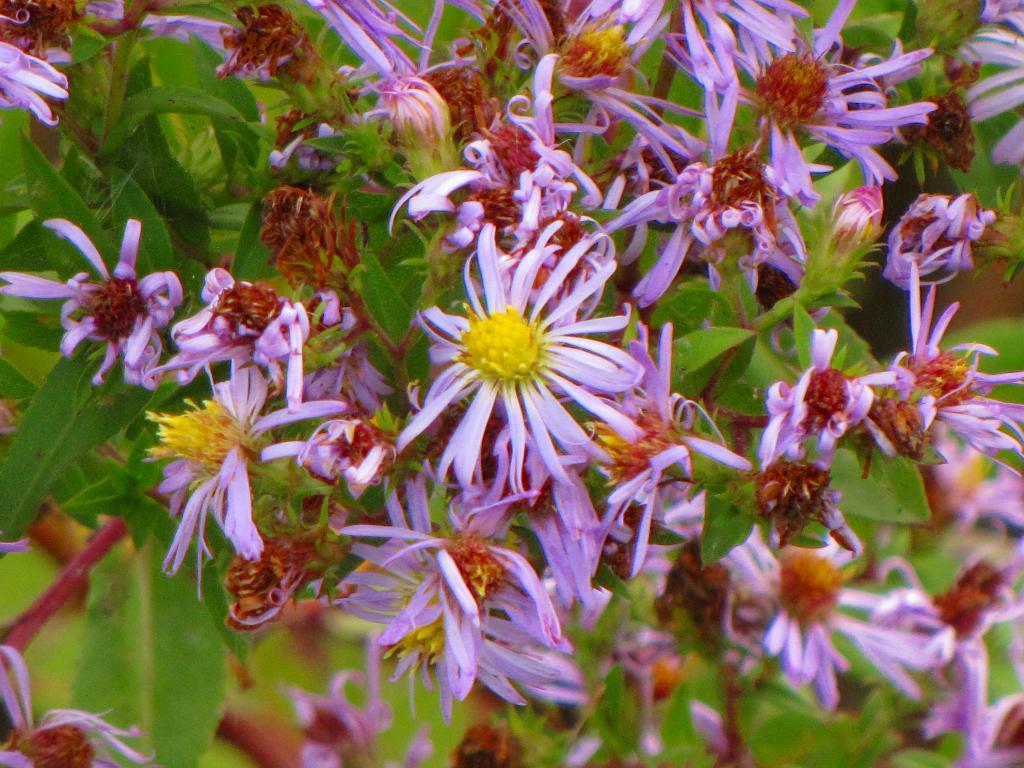Describe this image in one or two sentences. In this image I can see few purple,yellow and brown color flowers. Background I can see few green color leaves. 